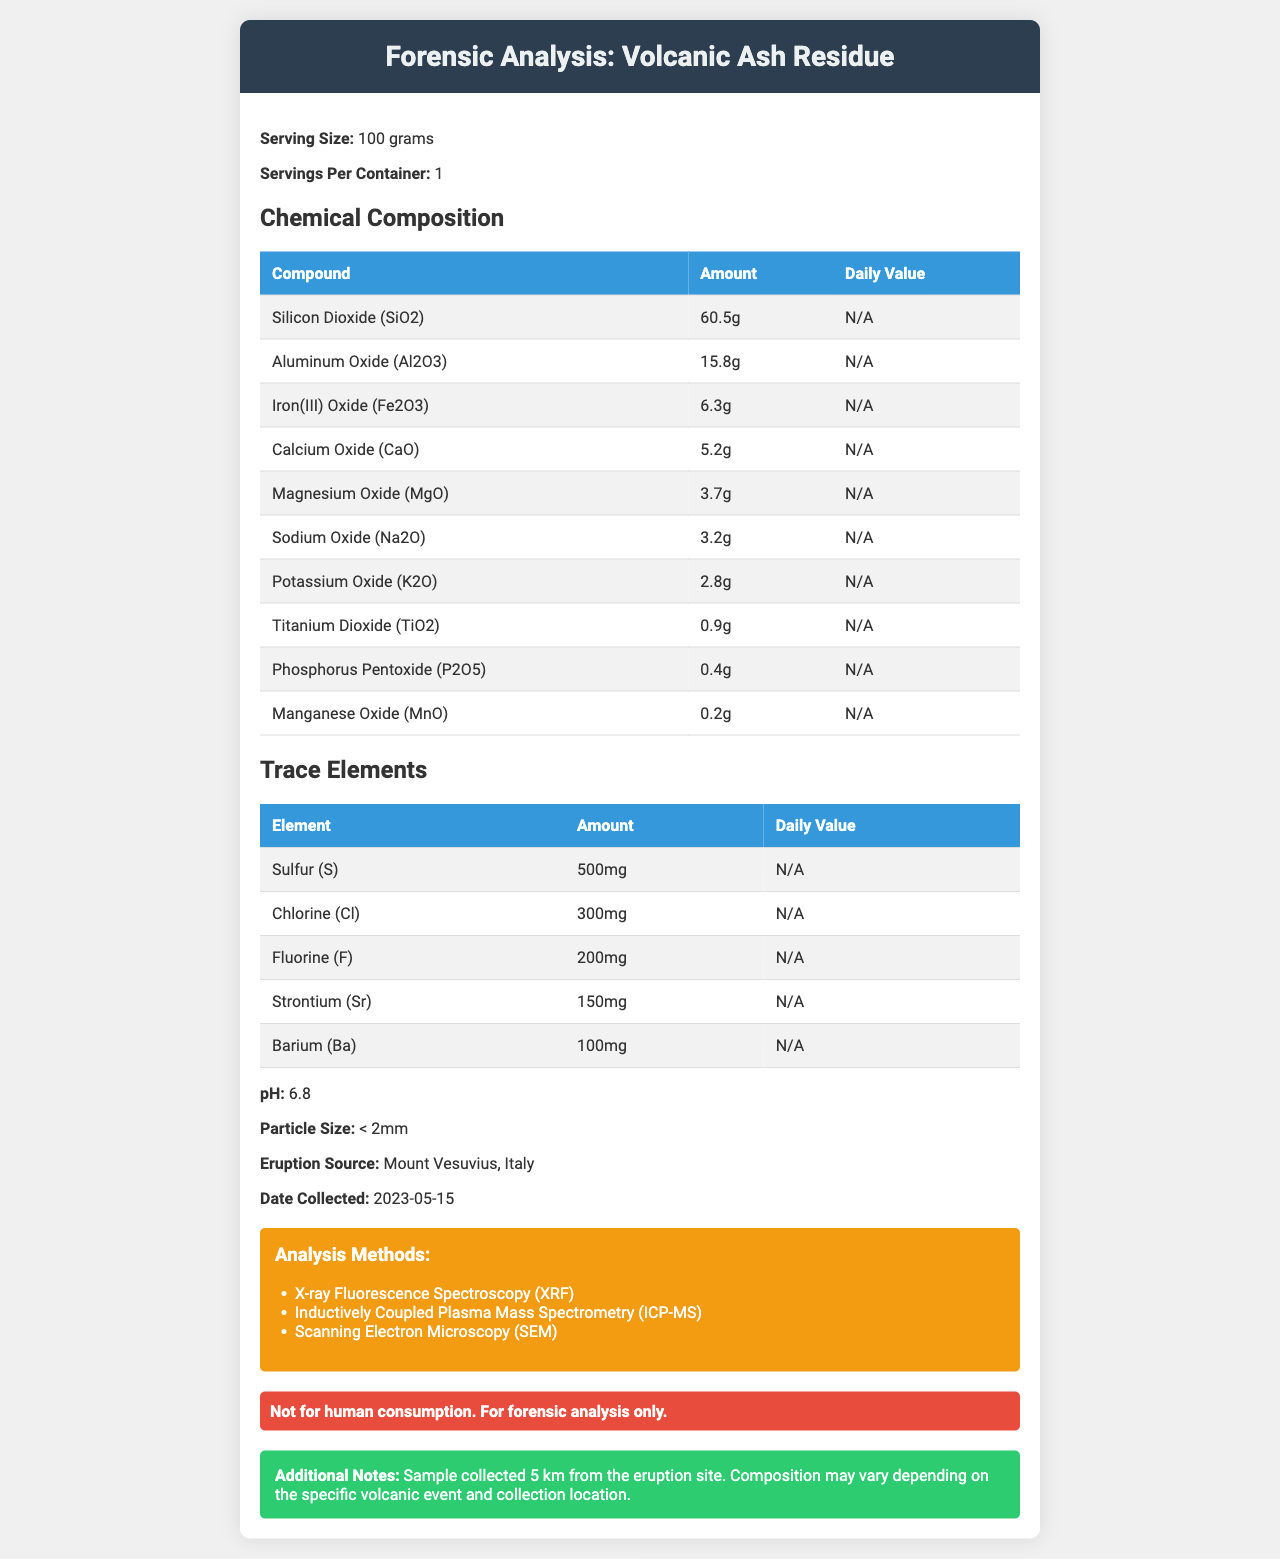what is the serving size mentioned in the document? The serving size is mentioned at the beginning of the document under the header "Serving Size".
Answer: 100 grams how much Silicon Dioxide (SiO2) is present in the composition? This is listed under the "Chemical Composition" table in the document.
Answer: 60.5g what is the particle size of the volcanic ash residue? The particle size is mentioned towards the middle of the document.
Answer: < 2mm which oxide is found in the greatest amount in the volcanic ash residue? SiO2 has the highest amount of 60.5g listed in the "Chemical Composition" section.
Answer: Silicon Dioxide (SiO2) what is the pH value of the volcanic ash residue? The pH value is listed towards the middle of the document.
Answer: 6.8 which element is present in the smallest trace amount? A. Sulfur (S) B. Chlorine (Cl) C. Barium (Ba) Barium is present in the smallest trace amount of 100mg.
Answer: C. Barium (Ba) how many grams of Iron(III) Oxide (Fe2O3) does the volcanic ash contain? A. 6.3g B. 0.9g C. 5.2g D. 3.7g Iron(III) Oxide (Fe2O3) is listed as 6.3g in the "Chemical Composition" section.
Answer: A. 6.3g is the volcanic ash residue safe for human consumption? The warning statement in the document clearly mentions: "Not for human consumption. For forensic analysis only."
Answer: No briefly summarize the main idea of the document. The document details the chemical makeup and analysis methods of a volcanic ash sample with relevant information regarding its collection and analysis.
Answer: The document provides the forensic analysis of a volcanic ash residue sample collected from Mount Vesuvius. It lists the serving size, chemical composition, trace elements, pH, particle size, eruption source, date collected, analysis methods used, and includes a warning statement that the product is not for human consumption. how was the sample analyzed? The analysis methods stated in the document are X-ray Fluorescence Spectroscopy (XRF), Inductively Coupled Plasma Mass Spectrometry (ICP-MS), and Scanning Electron Microscopy (SEM).
Answer: XRF, ICP-MS, SEM what is the exact location and date of the volcanic ash collection? The document mentions that the sample was collected from Mount Vesuvius, Italy on May 15, 2023.
Answer: Mount Vesuvius, Italy, 2023-05-15 what are the daily values of the chemical compounds listed in the document? The document states "N/A" for the daily values of all listed chemical compounds.
Answer: Not provided which analysis method was used? The document lists three analysis methods (XRF, ICP-MS, SEM) but does not specify which exact method was used for each compound or element.
Answer: Not enough information 